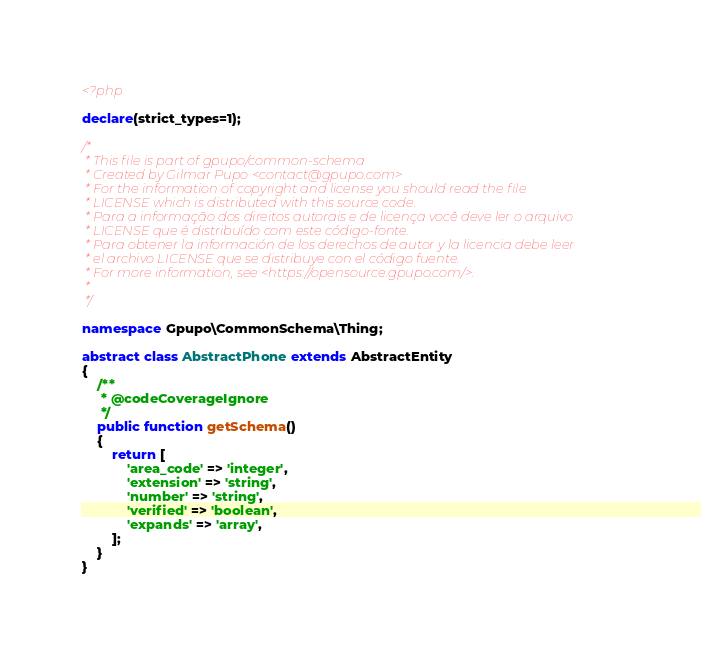<code> <loc_0><loc_0><loc_500><loc_500><_PHP_><?php

declare(strict_types=1);

/*
 * This file is part of gpupo/common-schema
 * Created by Gilmar Pupo <contact@gpupo.com>
 * For the information of copyright and license you should read the file
 * LICENSE which is distributed with this source code.
 * Para a informação dos direitos autorais e de licença você deve ler o arquivo
 * LICENSE que é distribuído com este código-fonte.
 * Para obtener la información de los derechos de autor y la licencia debe leer
 * el archivo LICENSE que se distribuye con el código fuente.
 * For more information, see <https://opensource.gpupo.com/>.
 *
 */

namespace Gpupo\CommonSchema\Thing;

abstract class AbstractPhone extends AbstractEntity
{
    /**
     * @codeCoverageIgnore
     */
    public function getSchema()
    {
        return [
            'area_code' => 'integer',
            'extension' => 'string',
            'number' => 'string',
            'verified' => 'boolean',
            'expands' => 'array',
        ];
    }
}
</code> 